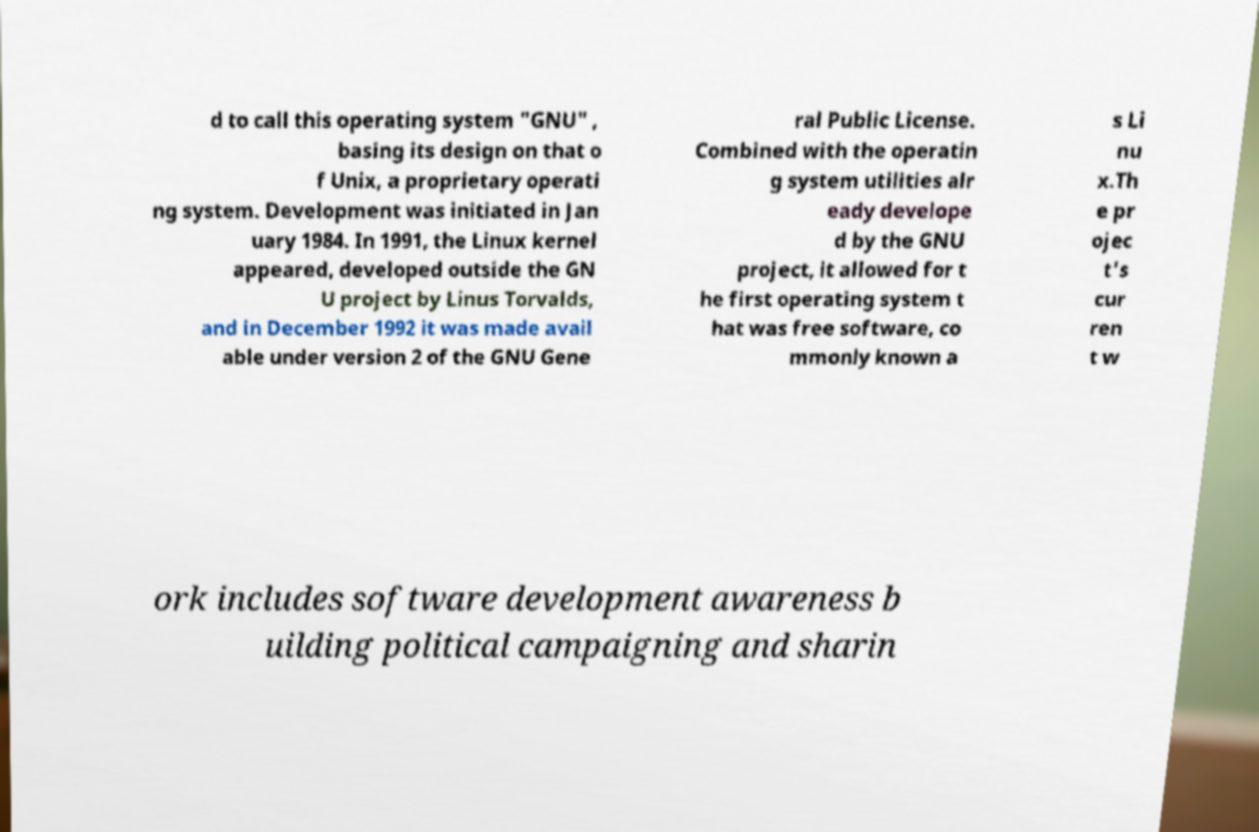Can you read and provide the text displayed in the image?This photo seems to have some interesting text. Can you extract and type it out for me? d to call this operating system "GNU" , basing its design on that o f Unix, a proprietary operati ng system. Development was initiated in Jan uary 1984. In 1991, the Linux kernel appeared, developed outside the GN U project by Linus Torvalds, and in December 1992 it was made avail able under version 2 of the GNU Gene ral Public License. Combined with the operatin g system utilities alr eady develope d by the GNU project, it allowed for t he first operating system t hat was free software, co mmonly known a s Li nu x.Th e pr ojec t's cur ren t w ork includes software development awareness b uilding political campaigning and sharin 